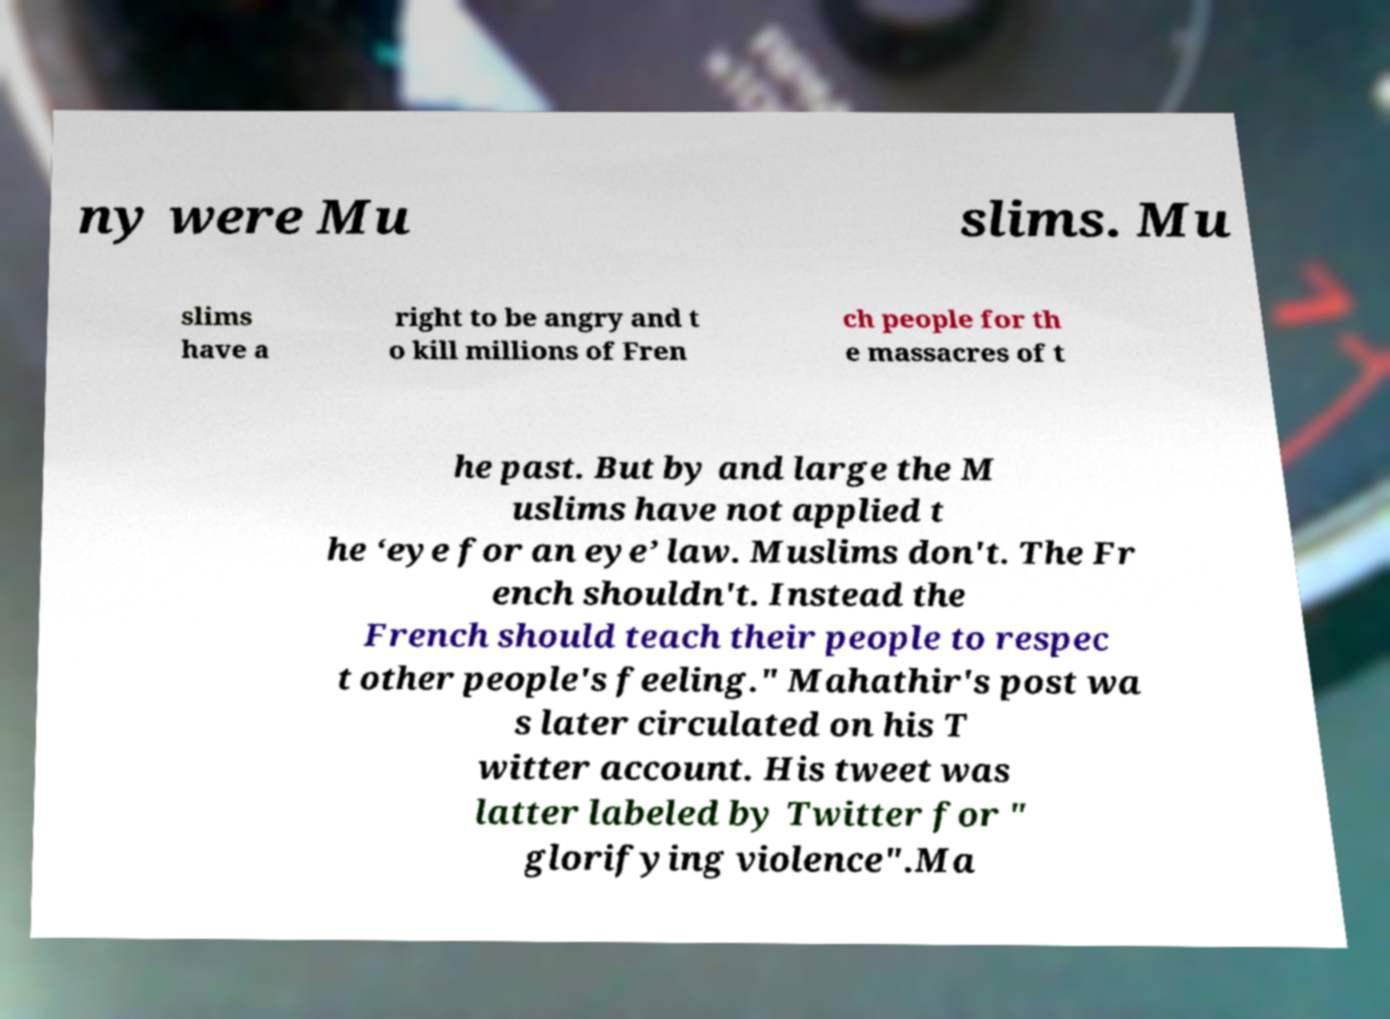For documentation purposes, I need the text within this image transcribed. Could you provide that? ny were Mu slims. Mu slims have a right to be angry and t o kill millions of Fren ch people for th e massacres of t he past. But by and large the M uslims have not applied t he ‘eye for an eye’ law. Muslims don't. The Fr ench shouldn't. Instead the French should teach their people to respec t other people's feeling." Mahathir's post wa s later circulated on his T witter account. His tweet was latter labeled by Twitter for " glorifying violence".Ma 